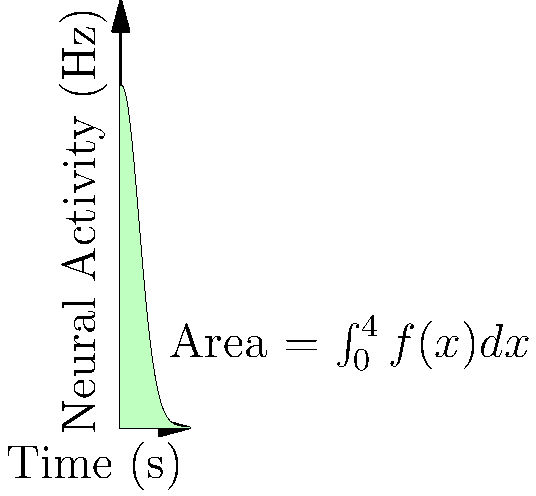The graph represents the neural activity in response to a taste stimulus over time. The function describing this activity is given by $f(x) = 20e^{-0.5x^2}$, where $x$ is time in seconds and $f(x)$ is the firing rate in Hz. Calculate the total neural activity (in Hz·s) over the 4-second interval by finding the area under the curve. To find the total neural activity, we need to calculate the area under the curve using integration:

1) The integral we need to evaluate is:
   $$\int_0^4 20e^{-0.5x^2} dx$$

2) This integral doesn't have an elementary antiderivative, so we need to use numerical integration or special functions.

3) Using the error function (erf), we can express this integral as:
   $$20\sqrt{\frac{\pi}{2}} \cdot \text{erf}\left(\frac{x}{\sqrt{2}}\right)\bigg|_0^4$$

4) Evaluating at the limits:
   $$20\sqrt{\frac{\pi}{2}} \cdot \left(\text{erf}\left(\frac{4}{\sqrt{2}}\right) - \text{erf}(0)\right)$$

5) $\text{erf}(0) = 0$ and $\text{erf}\left(\frac{4}{\sqrt{2}}\right) \approx 0.9995$

6) Substituting these values:
   $$20\sqrt{\frac{\pi}{2}} \cdot 0.9995 \approx 25.06$$

Therefore, the total neural activity over the 4-second interval is approximately 25.06 Hz·s.
Answer: 25.06 Hz·s 